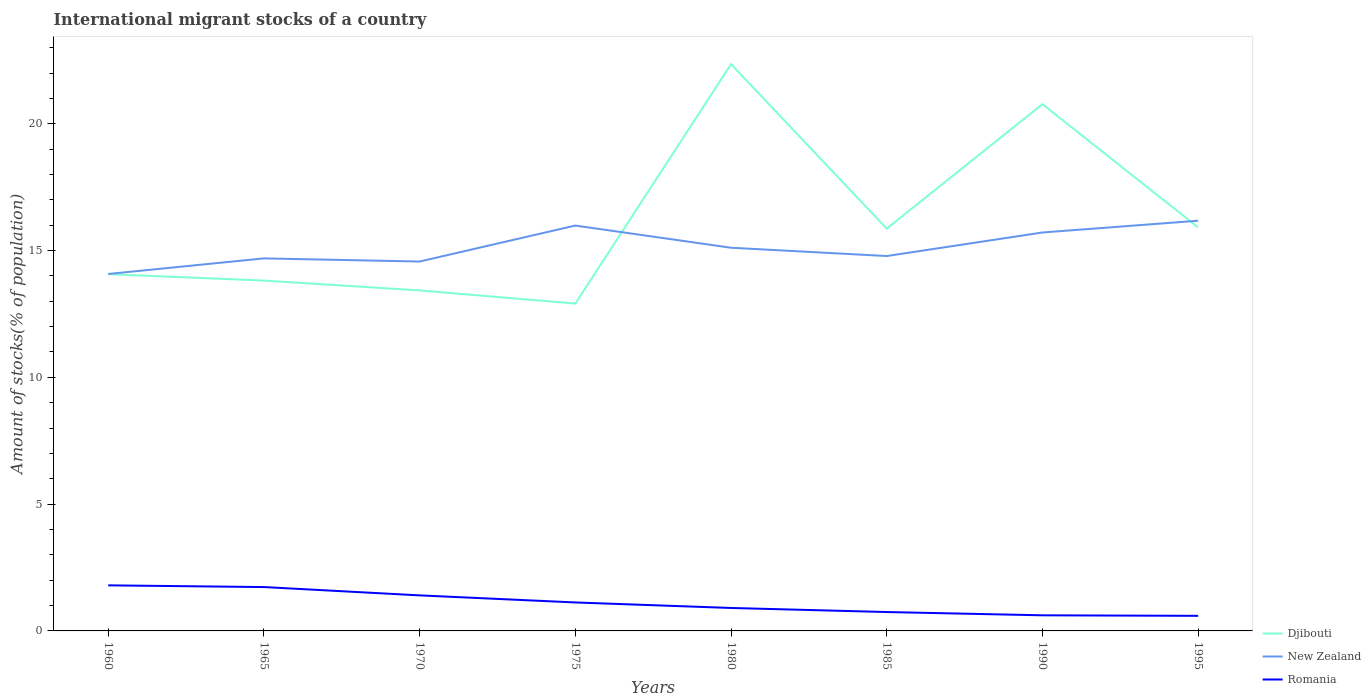How many different coloured lines are there?
Provide a succinct answer. 3. Across all years, what is the maximum amount of stocks in in Romania?
Provide a succinct answer. 0.6. In which year was the amount of stocks in in New Zealand maximum?
Your response must be concise. 1960. What is the total amount of stocks in in Djibouti in the graph?
Keep it short and to the point. -3. What is the difference between the highest and the second highest amount of stocks in in Djibouti?
Keep it short and to the point. 9.44. What is the difference between the highest and the lowest amount of stocks in in Romania?
Offer a terse response. 4. Is the amount of stocks in in New Zealand strictly greater than the amount of stocks in in Djibouti over the years?
Your response must be concise. No. How many lines are there?
Your answer should be very brief. 3. Where does the legend appear in the graph?
Make the answer very short. Bottom right. How are the legend labels stacked?
Your response must be concise. Vertical. What is the title of the graph?
Your answer should be compact. International migrant stocks of a country. What is the label or title of the X-axis?
Make the answer very short. Years. What is the label or title of the Y-axis?
Give a very brief answer. Amount of stocks(% of population). What is the Amount of stocks(% of population) in Djibouti in 1960?
Provide a succinct answer. 14.07. What is the Amount of stocks(% of population) in New Zealand in 1960?
Your answer should be very brief. 14.08. What is the Amount of stocks(% of population) of Romania in 1960?
Your response must be concise. 1.8. What is the Amount of stocks(% of population) of Djibouti in 1965?
Ensure brevity in your answer.  13.82. What is the Amount of stocks(% of population) of New Zealand in 1965?
Your answer should be very brief. 14.69. What is the Amount of stocks(% of population) of Romania in 1965?
Ensure brevity in your answer.  1.73. What is the Amount of stocks(% of population) in Djibouti in 1970?
Keep it short and to the point. 13.43. What is the Amount of stocks(% of population) in New Zealand in 1970?
Keep it short and to the point. 14.57. What is the Amount of stocks(% of population) of Romania in 1970?
Provide a succinct answer. 1.4. What is the Amount of stocks(% of population) in Djibouti in 1975?
Keep it short and to the point. 12.91. What is the Amount of stocks(% of population) in New Zealand in 1975?
Your answer should be very brief. 15.99. What is the Amount of stocks(% of population) in Romania in 1975?
Ensure brevity in your answer.  1.12. What is the Amount of stocks(% of population) of Djibouti in 1980?
Provide a succinct answer. 22.35. What is the Amount of stocks(% of population) in New Zealand in 1980?
Your answer should be compact. 15.11. What is the Amount of stocks(% of population) in Romania in 1980?
Provide a succinct answer. 0.91. What is the Amount of stocks(% of population) of Djibouti in 1985?
Provide a succinct answer. 15.87. What is the Amount of stocks(% of population) in New Zealand in 1985?
Offer a very short reply. 14.78. What is the Amount of stocks(% of population) of Romania in 1985?
Offer a very short reply. 0.75. What is the Amount of stocks(% of population) in Djibouti in 1990?
Your answer should be very brief. 20.77. What is the Amount of stocks(% of population) of New Zealand in 1990?
Give a very brief answer. 15.71. What is the Amount of stocks(% of population) of Romania in 1990?
Make the answer very short. 0.62. What is the Amount of stocks(% of population) of Djibouti in 1995?
Give a very brief answer. 15.91. What is the Amount of stocks(% of population) in New Zealand in 1995?
Keep it short and to the point. 16.18. What is the Amount of stocks(% of population) in Romania in 1995?
Your response must be concise. 0.6. Across all years, what is the maximum Amount of stocks(% of population) in Djibouti?
Offer a terse response. 22.35. Across all years, what is the maximum Amount of stocks(% of population) of New Zealand?
Your answer should be very brief. 16.18. Across all years, what is the maximum Amount of stocks(% of population) of Romania?
Offer a very short reply. 1.8. Across all years, what is the minimum Amount of stocks(% of population) of Djibouti?
Your response must be concise. 12.91. Across all years, what is the minimum Amount of stocks(% of population) of New Zealand?
Your answer should be compact. 14.08. Across all years, what is the minimum Amount of stocks(% of population) in Romania?
Your answer should be very brief. 0.6. What is the total Amount of stocks(% of population) in Djibouti in the graph?
Your response must be concise. 129.12. What is the total Amount of stocks(% of population) of New Zealand in the graph?
Provide a short and direct response. 121.1. What is the total Amount of stocks(% of population) of Romania in the graph?
Keep it short and to the point. 8.91. What is the difference between the Amount of stocks(% of population) of Djibouti in 1960 and that in 1965?
Offer a very short reply. 0.25. What is the difference between the Amount of stocks(% of population) in New Zealand in 1960 and that in 1965?
Provide a short and direct response. -0.62. What is the difference between the Amount of stocks(% of population) of Romania in 1960 and that in 1965?
Offer a terse response. 0.07. What is the difference between the Amount of stocks(% of population) of Djibouti in 1960 and that in 1970?
Provide a short and direct response. 0.64. What is the difference between the Amount of stocks(% of population) in New Zealand in 1960 and that in 1970?
Provide a succinct answer. -0.49. What is the difference between the Amount of stocks(% of population) of Romania in 1960 and that in 1970?
Your answer should be very brief. 0.4. What is the difference between the Amount of stocks(% of population) in Djibouti in 1960 and that in 1975?
Ensure brevity in your answer.  1.16. What is the difference between the Amount of stocks(% of population) of New Zealand in 1960 and that in 1975?
Provide a succinct answer. -1.91. What is the difference between the Amount of stocks(% of population) in Romania in 1960 and that in 1975?
Keep it short and to the point. 0.68. What is the difference between the Amount of stocks(% of population) in Djibouti in 1960 and that in 1980?
Provide a short and direct response. -8.28. What is the difference between the Amount of stocks(% of population) in New Zealand in 1960 and that in 1980?
Ensure brevity in your answer.  -1.03. What is the difference between the Amount of stocks(% of population) of Romania in 1960 and that in 1980?
Keep it short and to the point. 0.89. What is the difference between the Amount of stocks(% of population) of Djibouti in 1960 and that in 1985?
Provide a succinct answer. -1.8. What is the difference between the Amount of stocks(% of population) of New Zealand in 1960 and that in 1985?
Keep it short and to the point. -0.71. What is the difference between the Amount of stocks(% of population) of Romania in 1960 and that in 1985?
Provide a succinct answer. 1.05. What is the difference between the Amount of stocks(% of population) in Djibouti in 1960 and that in 1990?
Offer a terse response. -6.71. What is the difference between the Amount of stocks(% of population) in New Zealand in 1960 and that in 1990?
Give a very brief answer. -1.64. What is the difference between the Amount of stocks(% of population) in Romania in 1960 and that in 1990?
Provide a succinct answer. 1.18. What is the difference between the Amount of stocks(% of population) of Djibouti in 1960 and that in 1995?
Provide a short and direct response. -1.84. What is the difference between the Amount of stocks(% of population) in New Zealand in 1960 and that in 1995?
Make the answer very short. -2.1. What is the difference between the Amount of stocks(% of population) in Romania in 1960 and that in 1995?
Provide a short and direct response. 1.2. What is the difference between the Amount of stocks(% of population) in Djibouti in 1965 and that in 1970?
Offer a terse response. 0.39. What is the difference between the Amount of stocks(% of population) in New Zealand in 1965 and that in 1970?
Offer a terse response. 0.12. What is the difference between the Amount of stocks(% of population) in Romania in 1965 and that in 1970?
Give a very brief answer. 0.33. What is the difference between the Amount of stocks(% of population) of Djibouti in 1965 and that in 1975?
Offer a terse response. 0.91. What is the difference between the Amount of stocks(% of population) of New Zealand in 1965 and that in 1975?
Your response must be concise. -1.29. What is the difference between the Amount of stocks(% of population) in Romania in 1965 and that in 1975?
Your answer should be compact. 0.61. What is the difference between the Amount of stocks(% of population) of Djibouti in 1965 and that in 1980?
Your answer should be compact. -8.53. What is the difference between the Amount of stocks(% of population) in New Zealand in 1965 and that in 1980?
Your answer should be very brief. -0.42. What is the difference between the Amount of stocks(% of population) in Romania in 1965 and that in 1980?
Provide a succinct answer. 0.82. What is the difference between the Amount of stocks(% of population) in Djibouti in 1965 and that in 1985?
Give a very brief answer. -2.05. What is the difference between the Amount of stocks(% of population) of New Zealand in 1965 and that in 1985?
Your response must be concise. -0.09. What is the difference between the Amount of stocks(% of population) in Romania in 1965 and that in 1985?
Ensure brevity in your answer.  0.98. What is the difference between the Amount of stocks(% of population) in Djibouti in 1965 and that in 1990?
Ensure brevity in your answer.  -6.96. What is the difference between the Amount of stocks(% of population) in New Zealand in 1965 and that in 1990?
Offer a terse response. -1.02. What is the difference between the Amount of stocks(% of population) of Romania in 1965 and that in 1990?
Ensure brevity in your answer.  1.11. What is the difference between the Amount of stocks(% of population) of Djibouti in 1965 and that in 1995?
Provide a short and direct response. -2.1. What is the difference between the Amount of stocks(% of population) of New Zealand in 1965 and that in 1995?
Give a very brief answer. -1.49. What is the difference between the Amount of stocks(% of population) in Romania in 1965 and that in 1995?
Keep it short and to the point. 1.13. What is the difference between the Amount of stocks(% of population) in Djibouti in 1970 and that in 1975?
Your answer should be very brief. 0.52. What is the difference between the Amount of stocks(% of population) of New Zealand in 1970 and that in 1975?
Offer a terse response. -1.42. What is the difference between the Amount of stocks(% of population) of Romania in 1970 and that in 1975?
Offer a very short reply. 0.28. What is the difference between the Amount of stocks(% of population) of Djibouti in 1970 and that in 1980?
Your response must be concise. -8.92. What is the difference between the Amount of stocks(% of population) in New Zealand in 1970 and that in 1980?
Your answer should be compact. -0.54. What is the difference between the Amount of stocks(% of population) in Romania in 1970 and that in 1980?
Your answer should be very brief. 0.5. What is the difference between the Amount of stocks(% of population) of Djibouti in 1970 and that in 1985?
Your answer should be compact. -2.44. What is the difference between the Amount of stocks(% of population) in New Zealand in 1970 and that in 1985?
Offer a terse response. -0.22. What is the difference between the Amount of stocks(% of population) of Romania in 1970 and that in 1985?
Offer a very short reply. 0.66. What is the difference between the Amount of stocks(% of population) of Djibouti in 1970 and that in 1990?
Keep it short and to the point. -7.35. What is the difference between the Amount of stocks(% of population) in New Zealand in 1970 and that in 1990?
Give a very brief answer. -1.15. What is the difference between the Amount of stocks(% of population) of Romania in 1970 and that in 1990?
Give a very brief answer. 0.79. What is the difference between the Amount of stocks(% of population) of Djibouti in 1970 and that in 1995?
Make the answer very short. -2.48. What is the difference between the Amount of stocks(% of population) in New Zealand in 1970 and that in 1995?
Provide a succinct answer. -1.61. What is the difference between the Amount of stocks(% of population) of Romania in 1970 and that in 1995?
Keep it short and to the point. 0.81. What is the difference between the Amount of stocks(% of population) in Djibouti in 1975 and that in 1980?
Make the answer very short. -9.44. What is the difference between the Amount of stocks(% of population) in New Zealand in 1975 and that in 1980?
Provide a short and direct response. 0.87. What is the difference between the Amount of stocks(% of population) of Romania in 1975 and that in 1980?
Your response must be concise. 0.22. What is the difference between the Amount of stocks(% of population) in Djibouti in 1975 and that in 1985?
Give a very brief answer. -2.96. What is the difference between the Amount of stocks(% of population) of New Zealand in 1975 and that in 1985?
Keep it short and to the point. 1.2. What is the difference between the Amount of stocks(% of population) of Romania in 1975 and that in 1985?
Make the answer very short. 0.38. What is the difference between the Amount of stocks(% of population) in Djibouti in 1975 and that in 1990?
Give a very brief answer. -7.86. What is the difference between the Amount of stocks(% of population) in New Zealand in 1975 and that in 1990?
Provide a succinct answer. 0.27. What is the difference between the Amount of stocks(% of population) of Romania in 1975 and that in 1990?
Your answer should be very brief. 0.51. What is the difference between the Amount of stocks(% of population) in Djibouti in 1975 and that in 1995?
Provide a succinct answer. -3. What is the difference between the Amount of stocks(% of population) of New Zealand in 1975 and that in 1995?
Offer a terse response. -0.19. What is the difference between the Amount of stocks(% of population) of Romania in 1975 and that in 1995?
Keep it short and to the point. 0.53. What is the difference between the Amount of stocks(% of population) in Djibouti in 1980 and that in 1985?
Provide a succinct answer. 6.48. What is the difference between the Amount of stocks(% of population) in New Zealand in 1980 and that in 1985?
Give a very brief answer. 0.33. What is the difference between the Amount of stocks(% of population) in Romania in 1980 and that in 1985?
Ensure brevity in your answer.  0.16. What is the difference between the Amount of stocks(% of population) in Djibouti in 1980 and that in 1990?
Your answer should be very brief. 1.58. What is the difference between the Amount of stocks(% of population) of New Zealand in 1980 and that in 1990?
Offer a terse response. -0.6. What is the difference between the Amount of stocks(% of population) in Romania in 1980 and that in 1990?
Your answer should be compact. 0.29. What is the difference between the Amount of stocks(% of population) in Djibouti in 1980 and that in 1995?
Provide a succinct answer. 6.44. What is the difference between the Amount of stocks(% of population) of New Zealand in 1980 and that in 1995?
Provide a succinct answer. -1.07. What is the difference between the Amount of stocks(% of population) of Romania in 1980 and that in 1995?
Your answer should be compact. 0.31. What is the difference between the Amount of stocks(% of population) in Djibouti in 1985 and that in 1990?
Make the answer very short. -4.91. What is the difference between the Amount of stocks(% of population) in New Zealand in 1985 and that in 1990?
Make the answer very short. -0.93. What is the difference between the Amount of stocks(% of population) of Romania in 1985 and that in 1990?
Your answer should be very brief. 0.13. What is the difference between the Amount of stocks(% of population) in Djibouti in 1985 and that in 1995?
Offer a terse response. -0.05. What is the difference between the Amount of stocks(% of population) in New Zealand in 1985 and that in 1995?
Ensure brevity in your answer.  -1.39. What is the difference between the Amount of stocks(% of population) of Romania in 1985 and that in 1995?
Offer a very short reply. 0.15. What is the difference between the Amount of stocks(% of population) in Djibouti in 1990 and that in 1995?
Offer a very short reply. 4.86. What is the difference between the Amount of stocks(% of population) of New Zealand in 1990 and that in 1995?
Provide a short and direct response. -0.46. What is the difference between the Amount of stocks(% of population) in Romania in 1990 and that in 1995?
Keep it short and to the point. 0.02. What is the difference between the Amount of stocks(% of population) of Djibouti in 1960 and the Amount of stocks(% of population) of New Zealand in 1965?
Your answer should be compact. -0.62. What is the difference between the Amount of stocks(% of population) of Djibouti in 1960 and the Amount of stocks(% of population) of Romania in 1965?
Offer a very short reply. 12.34. What is the difference between the Amount of stocks(% of population) of New Zealand in 1960 and the Amount of stocks(% of population) of Romania in 1965?
Offer a terse response. 12.35. What is the difference between the Amount of stocks(% of population) in Djibouti in 1960 and the Amount of stocks(% of population) in New Zealand in 1970?
Provide a succinct answer. -0.5. What is the difference between the Amount of stocks(% of population) in Djibouti in 1960 and the Amount of stocks(% of population) in Romania in 1970?
Ensure brevity in your answer.  12.67. What is the difference between the Amount of stocks(% of population) of New Zealand in 1960 and the Amount of stocks(% of population) of Romania in 1970?
Your answer should be compact. 12.67. What is the difference between the Amount of stocks(% of population) in Djibouti in 1960 and the Amount of stocks(% of population) in New Zealand in 1975?
Your answer should be compact. -1.92. What is the difference between the Amount of stocks(% of population) in Djibouti in 1960 and the Amount of stocks(% of population) in Romania in 1975?
Ensure brevity in your answer.  12.95. What is the difference between the Amount of stocks(% of population) in New Zealand in 1960 and the Amount of stocks(% of population) in Romania in 1975?
Your answer should be compact. 12.95. What is the difference between the Amount of stocks(% of population) in Djibouti in 1960 and the Amount of stocks(% of population) in New Zealand in 1980?
Keep it short and to the point. -1.04. What is the difference between the Amount of stocks(% of population) in Djibouti in 1960 and the Amount of stocks(% of population) in Romania in 1980?
Ensure brevity in your answer.  13.16. What is the difference between the Amount of stocks(% of population) in New Zealand in 1960 and the Amount of stocks(% of population) in Romania in 1980?
Ensure brevity in your answer.  13.17. What is the difference between the Amount of stocks(% of population) of Djibouti in 1960 and the Amount of stocks(% of population) of New Zealand in 1985?
Offer a very short reply. -0.72. What is the difference between the Amount of stocks(% of population) in Djibouti in 1960 and the Amount of stocks(% of population) in Romania in 1985?
Give a very brief answer. 13.32. What is the difference between the Amount of stocks(% of population) of New Zealand in 1960 and the Amount of stocks(% of population) of Romania in 1985?
Offer a very short reply. 13.33. What is the difference between the Amount of stocks(% of population) of Djibouti in 1960 and the Amount of stocks(% of population) of New Zealand in 1990?
Your answer should be very brief. -1.64. What is the difference between the Amount of stocks(% of population) of Djibouti in 1960 and the Amount of stocks(% of population) of Romania in 1990?
Your response must be concise. 13.45. What is the difference between the Amount of stocks(% of population) of New Zealand in 1960 and the Amount of stocks(% of population) of Romania in 1990?
Your answer should be compact. 13.46. What is the difference between the Amount of stocks(% of population) in Djibouti in 1960 and the Amount of stocks(% of population) in New Zealand in 1995?
Provide a short and direct response. -2.11. What is the difference between the Amount of stocks(% of population) in Djibouti in 1960 and the Amount of stocks(% of population) in Romania in 1995?
Give a very brief answer. 13.47. What is the difference between the Amount of stocks(% of population) of New Zealand in 1960 and the Amount of stocks(% of population) of Romania in 1995?
Provide a short and direct response. 13.48. What is the difference between the Amount of stocks(% of population) in Djibouti in 1965 and the Amount of stocks(% of population) in New Zealand in 1970?
Give a very brief answer. -0.75. What is the difference between the Amount of stocks(% of population) in Djibouti in 1965 and the Amount of stocks(% of population) in Romania in 1970?
Your answer should be compact. 12.41. What is the difference between the Amount of stocks(% of population) in New Zealand in 1965 and the Amount of stocks(% of population) in Romania in 1970?
Your response must be concise. 13.29. What is the difference between the Amount of stocks(% of population) of Djibouti in 1965 and the Amount of stocks(% of population) of New Zealand in 1975?
Offer a very short reply. -2.17. What is the difference between the Amount of stocks(% of population) in Djibouti in 1965 and the Amount of stocks(% of population) in Romania in 1975?
Your answer should be very brief. 12.69. What is the difference between the Amount of stocks(% of population) of New Zealand in 1965 and the Amount of stocks(% of population) of Romania in 1975?
Your response must be concise. 13.57. What is the difference between the Amount of stocks(% of population) in Djibouti in 1965 and the Amount of stocks(% of population) in New Zealand in 1980?
Offer a terse response. -1.3. What is the difference between the Amount of stocks(% of population) in Djibouti in 1965 and the Amount of stocks(% of population) in Romania in 1980?
Keep it short and to the point. 12.91. What is the difference between the Amount of stocks(% of population) in New Zealand in 1965 and the Amount of stocks(% of population) in Romania in 1980?
Offer a terse response. 13.79. What is the difference between the Amount of stocks(% of population) in Djibouti in 1965 and the Amount of stocks(% of population) in New Zealand in 1985?
Provide a short and direct response. -0.97. What is the difference between the Amount of stocks(% of population) in Djibouti in 1965 and the Amount of stocks(% of population) in Romania in 1985?
Make the answer very short. 13.07. What is the difference between the Amount of stocks(% of population) in New Zealand in 1965 and the Amount of stocks(% of population) in Romania in 1985?
Keep it short and to the point. 13.95. What is the difference between the Amount of stocks(% of population) in Djibouti in 1965 and the Amount of stocks(% of population) in New Zealand in 1990?
Offer a very short reply. -1.9. What is the difference between the Amount of stocks(% of population) in Djibouti in 1965 and the Amount of stocks(% of population) in Romania in 1990?
Provide a succinct answer. 13.2. What is the difference between the Amount of stocks(% of population) of New Zealand in 1965 and the Amount of stocks(% of population) of Romania in 1990?
Offer a very short reply. 14.08. What is the difference between the Amount of stocks(% of population) of Djibouti in 1965 and the Amount of stocks(% of population) of New Zealand in 1995?
Your answer should be very brief. -2.36. What is the difference between the Amount of stocks(% of population) of Djibouti in 1965 and the Amount of stocks(% of population) of Romania in 1995?
Your answer should be very brief. 13.22. What is the difference between the Amount of stocks(% of population) of New Zealand in 1965 and the Amount of stocks(% of population) of Romania in 1995?
Make the answer very short. 14.1. What is the difference between the Amount of stocks(% of population) of Djibouti in 1970 and the Amount of stocks(% of population) of New Zealand in 1975?
Your answer should be compact. -2.56. What is the difference between the Amount of stocks(% of population) in Djibouti in 1970 and the Amount of stocks(% of population) in Romania in 1975?
Provide a short and direct response. 12.31. What is the difference between the Amount of stocks(% of population) in New Zealand in 1970 and the Amount of stocks(% of population) in Romania in 1975?
Offer a terse response. 13.44. What is the difference between the Amount of stocks(% of population) of Djibouti in 1970 and the Amount of stocks(% of population) of New Zealand in 1980?
Your answer should be very brief. -1.68. What is the difference between the Amount of stocks(% of population) in Djibouti in 1970 and the Amount of stocks(% of population) in Romania in 1980?
Make the answer very short. 12.52. What is the difference between the Amount of stocks(% of population) in New Zealand in 1970 and the Amount of stocks(% of population) in Romania in 1980?
Your answer should be compact. 13.66. What is the difference between the Amount of stocks(% of population) of Djibouti in 1970 and the Amount of stocks(% of population) of New Zealand in 1985?
Your answer should be compact. -1.36. What is the difference between the Amount of stocks(% of population) of Djibouti in 1970 and the Amount of stocks(% of population) of Romania in 1985?
Give a very brief answer. 12.68. What is the difference between the Amount of stocks(% of population) of New Zealand in 1970 and the Amount of stocks(% of population) of Romania in 1985?
Provide a succinct answer. 13.82. What is the difference between the Amount of stocks(% of population) of Djibouti in 1970 and the Amount of stocks(% of population) of New Zealand in 1990?
Offer a terse response. -2.28. What is the difference between the Amount of stocks(% of population) in Djibouti in 1970 and the Amount of stocks(% of population) in Romania in 1990?
Give a very brief answer. 12.81. What is the difference between the Amount of stocks(% of population) of New Zealand in 1970 and the Amount of stocks(% of population) of Romania in 1990?
Your answer should be compact. 13.95. What is the difference between the Amount of stocks(% of population) in Djibouti in 1970 and the Amount of stocks(% of population) in New Zealand in 1995?
Keep it short and to the point. -2.75. What is the difference between the Amount of stocks(% of population) in Djibouti in 1970 and the Amount of stocks(% of population) in Romania in 1995?
Provide a succinct answer. 12.83. What is the difference between the Amount of stocks(% of population) in New Zealand in 1970 and the Amount of stocks(% of population) in Romania in 1995?
Offer a very short reply. 13.97. What is the difference between the Amount of stocks(% of population) of Djibouti in 1975 and the Amount of stocks(% of population) of New Zealand in 1980?
Offer a very short reply. -2.2. What is the difference between the Amount of stocks(% of population) in Djibouti in 1975 and the Amount of stocks(% of population) in Romania in 1980?
Offer a terse response. 12. What is the difference between the Amount of stocks(% of population) of New Zealand in 1975 and the Amount of stocks(% of population) of Romania in 1980?
Your answer should be compact. 15.08. What is the difference between the Amount of stocks(% of population) in Djibouti in 1975 and the Amount of stocks(% of population) in New Zealand in 1985?
Provide a short and direct response. -1.87. What is the difference between the Amount of stocks(% of population) of Djibouti in 1975 and the Amount of stocks(% of population) of Romania in 1985?
Your answer should be compact. 12.16. What is the difference between the Amount of stocks(% of population) in New Zealand in 1975 and the Amount of stocks(% of population) in Romania in 1985?
Provide a short and direct response. 15.24. What is the difference between the Amount of stocks(% of population) of Djibouti in 1975 and the Amount of stocks(% of population) of New Zealand in 1990?
Your answer should be compact. -2.8. What is the difference between the Amount of stocks(% of population) in Djibouti in 1975 and the Amount of stocks(% of population) in Romania in 1990?
Keep it short and to the point. 12.29. What is the difference between the Amount of stocks(% of population) in New Zealand in 1975 and the Amount of stocks(% of population) in Romania in 1990?
Your answer should be very brief. 15.37. What is the difference between the Amount of stocks(% of population) of Djibouti in 1975 and the Amount of stocks(% of population) of New Zealand in 1995?
Provide a succinct answer. -3.27. What is the difference between the Amount of stocks(% of population) in Djibouti in 1975 and the Amount of stocks(% of population) in Romania in 1995?
Provide a succinct answer. 12.31. What is the difference between the Amount of stocks(% of population) in New Zealand in 1975 and the Amount of stocks(% of population) in Romania in 1995?
Make the answer very short. 15.39. What is the difference between the Amount of stocks(% of population) of Djibouti in 1980 and the Amount of stocks(% of population) of New Zealand in 1985?
Your answer should be compact. 7.57. What is the difference between the Amount of stocks(% of population) of Djibouti in 1980 and the Amount of stocks(% of population) of Romania in 1985?
Your response must be concise. 21.61. What is the difference between the Amount of stocks(% of population) of New Zealand in 1980 and the Amount of stocks(% of population) of Romania in 1985?
Your answer should be compact. 14.37. What is the difference between the Amount of stocks(% of population) in Djibouti in 1980 and the Amount of stocks(% of population) in New Zealand in 1990?
Offer a terse response. 6.64. What is the difference between the Amount of stocks(% of population) of Djibouti in 1980 and the Amount of stocks(% of population) of Romania in 1990?
Provide a succinct answer. 21.74. What is the difference between the Amount of stocks(% of population) in New Zealand in 1980 and the Amount of stocks(% of population) in Romania in 1990?
Your answer should be very brief. 14.5. What is the difference between the Amount of stocks(% of population) in Djibouti in 1980 and the Amount of stocks(% of population) in New Zealand in 1995?
Give a very brief answer. 6.17. What is the difference between the Amount of stocks(% of population) in Djibouti in 1980 and the Amount of stocks(% of population) in Romania in 1995?
Your answer should be very brief. 21.76. What is the difference between the Amount of stocks(% of population) in New Zealand in 1980 and the Amount of stocks(% of population) in Romania in 1995?
Your answer should be compact. 14.52. What is the difference between the Amount of stocks(% of population) in Djibouti in 1985 and the Amount of stocks(% of population) in New Zealand in 1990?
Make the answer very short. 0.15. What is the difference between the Amount of stocks(% of population) of Djibouti in 1985 and the Amount of stocks(% of population) of Romania in 1990?
Offer a very short reply. 15.25. What is the difference between the Amount of stocks(% of population) of New Zealand in 1985 and the Amount of stocks(% of population) of Romania in 1990?
Give a very brief answer. 14.17. What is the difference between the Amount of stocks(% of population) of Djibouti in 1985 and the Amount of stocks(% of population) of New Zealand in 1995?
Make the answer very short. -0.31. What is the difference between the Amount of stocks(% of population) in Djibouti in 1985 and the Amount of stocks(% of population) in Romania in 1995?
Ensure brevity in your answer.  15.27. What is the difference between the Amount of stocks(% of population) of New Zealand in 1985 and the Amount of stocks(% of population) of Romania in 1995?
Offer a terse response. 14.19. What is the difference between the Amount of stocks(% of population) in Djibouti in 1990 and the Amount of stocks(% of population) in New Zealand in 1995?
Your answer should be compact. 4.6. What is the difference between the Amount of stocks(% of population) in Djibouti in 1990 and the Amount of stocks(% of population) in Romania in 1995?
Offer a very short reply. 20.18. What is the difference between the Amount of stocks(% of population) in New Zealand in 1990 and the Amount of stocks(% of population) in Romania in 1995?
Keep it short and to the point. 15.12. What is the average Amount of stocks(% of population) of Djibouti per year?
Your answer should be compact. 16.14. What is the average Amount of stocks(% of population) in New Zealand per year?
Provide a succinct answer. 15.14. What is the average Amount of stocks(% of population) in Romania per year?
Keep it short and to the point. 1.11. In the year 1960, what is the difference between the Amount of stocks(% of population) in Djibouti and Amount of stocks(% of population) in New Zealand?
Offer a very short reply. -0.01. In the year 1960, what is the difference between the Amount of stocks(% of population) of Djibouti and Amount of stocks(% of population) of Romania?
Make the answer very short. 12.27. In the year 1960, what is the difference between the Amount of stocks(% of population) in New Zealand and Amount of stocks(% of population) in Romania?
Give a very brief answer. 12.28. In the year 1965, what is the difference between the Amount of stocks(% of population) in Djibouti and Amount of stocks(% of population) in New Zealand?
Provide a short and direct response. -0.88. In the year 1965, what is the difference between the Amount of stocks(% of population) in Djibouti and Amount of stocks(% of population) in Romania?
Your response must be concise. 12.09. In the year 1965, what is the difference between the Amount of stocks(% of population) in New Zealand and Amount of stocks(% of population) in Romania?
Your response must be concise. 12.96. In the year 1970, what is the difference between the Amount of stocks(% of population) in Djibouti and Amount of stocks(% of population) in New Zealand?
Give a very brief answer. -1.14. In the year 1970, what is the difference between the Amount of stocks(% of population) of Djibouti and Amount of stocks(% of population) of Romania?
Ensure brevity in your answer.  12.03. In the year 1970, what is the difference between the Amount of stocks(% of population) in New Zealand and Amount of stocks(% of population) in Romania?
Offer a very short reply. 13.17. In the year 1975, what is the difference between the Amount of stocks(% of population) of Djibouti and Amount of stocks(% of population) of New Zealand?
Your answer should be very brief. -3.08. In the year 1975, what is the difference between the Amount of stocks(% of population) of Djibouti and Amount of stocks(% of population) of Romania?
Your answer should be very brief. 11.79. In the year 1975, what is the difference between the Amount of stocks(% of population) of New Zealand and Amount of stocks(% of population) of Romania?
Your answer should be very brief. 14.86. In the year 1980, what is the difference between the Amount of stocks(% of population) in Djibouti and Amount of stocks(% of population) in New Zealand?
Offer a very short reply. 7.24. In the year 1980, what is the difference between the Amount of stocks(% of population) of Djibouti and Amount of stocks(% of population) of Romania?
Your answer should be compact. 21.45. In the year 1980, what is the difference between the Amount of stocks(% of population) of New Zealand and Amount of stocks(% of population) of Romania?
Offer a very short reply. 14.21. In the year 1985, what is the difference between the Amount of stocks(% of population) of Djibouti and Amount of stocks(% of population) of New Zealand?
Give a very brief answer. 1.08. In the year 1985, what is the difference between the Amount of stocks(% of population) in Djibouti and Amount of stocks(% of population) in Romania?
Make the answer very short. 15.12. In the year 1985, what is the difference between the Amount of stocks(% of population) of New Zealand and Amount of stocks(% of population) of Romania?
Give a very brief answer. 14.04. In the year 1990, what is the difference between the Amount of stocks(% of population) of Djibouti and Amount of stocks(% of population) of New Zealand?
Keep it short and to the point. 5.06. In the year 1990, what is the difference between the Amount of stocks(% of population) in Djibouti and Amount of stocks(% of population) in Romania?
Offer a very short reply. 20.16. In the year 1990, what is the difference between the Amount of stocks(% of population) of New Zealand and Amount of stocks(% of population) of Romania?
Your answer should be very brief. 15.1. In the year 1995, what is the difference between the Amount of stocks(% of population) of Djibouti and Amount of stocks(% of population) of New Zealand?
Provide a short and direct response. -0.26. In the year 1995, what is the difference between the Amount of stocks(% of population) in Djibouti and Amount of stocks(% of population) in Romania?
Ensure brevity in your answer.  15.32. In the year 1995, what is the difference between the Amount of stocks(% of population) in New Zealand and Amount of stocks(% of population) in Romania?
Your response must be concise. 15.58. What is the ratio of the Amount of stocks(% of population) of Djibouti in 1960 to that in 1965?
Provide a succinct answer. 1.02. What is the ratio of the Amount of stocks(% of population) of New Zealand in 1960 to that in 1965?
Offer a very short reply. 0.96. What is the ratio of the Amount of stocks(% of population) in Romania in 1960 to that in 1965?
Ensure brevity in your answer.  1.04. What is the ratio of the Amount of stocks(% of population) in Djibouti in 1960 to that in 1970?
Your answer should be compact. 1.05. What is the ratio of the Amount of stocks(% of population) of New Zealand in 1960 to that in 1970?
Give a very brief answer. 0.97. What is the ratio of the Amount of stocks(% of population) in Romania in 1960 to that in 1970?
Provide a succinct answer. 1.28. What is the ratio of the Amount of stocks(% of population) in Djibouti in 1960 to that in 1975?
Make the answer very short. 1.09. What is the ratio of the Amount of stocks(% of population) of New Zealand in 1960 to that in 1975?
Provide a short and direct response. 0.88. What is the ratio of the Amount of stocks(% of population) in Romania in 1960 to that in 1975?
Provide a short and direct response. 1.6. What is the ratio of the Amount of stocks(% of population) of Djibouti in 1960 to that in 1980?
Provide a succinct answer. 0.63. What is the ratio of the Amount of stocks(% of population) of New Zealand in 1960 to that in 1980?
Offer a terse response. 0.93. What is the ratio of the Amount of stocks(% of population) of Romania in 1960 to that in 1980?
Provide a succinct answer. 1.99. What is the ratio of the Amount of stocks(% of population) of Djibouti in 1960 to that in 1985?
Your response must be concise. 0.89. What is the ratio of the Amount of stocks(% of population) in New Zealand in 1960 to that in 1985?
Provide a short and direct response. 0.95. What is the ratio of the Amount of stocks(% of population) of Romania in 1960 to that in 1985?
Provide a short and direct response. 2.41. What is the ratio of the Amount of stocks(% of population) of Djibouti in 1960 to that in 1990?
Your answer should be very brief. 0.68. What is the ratio of the Amount of stocks(% of population) of New Zealand in 1960 to that in 1990?
Your answer should be compact. 0.9. What is the ratio of the Amount of stocks(% of population) of Romania in 1960 to that in 1990?
Give a very brief answer. 2.92. What is the ratio of the Amount of stocks(% of population) in Djibouti in 1960 to that in 1995?
Make the answer very short. 0.88. What is the ratio of the Amount of stocks(% of population) in New Zealand in 1960 to that in 1995?
Ensure brevity in your answer.  0.87. What is the ratio of the Amount of stocks(% of population) in Romania in 1960 to that in 1995?
Provide a short and direct response. 3.02. What is the ratio of the Amount of stocks(% of population) of Djibouti in 1965 to that in 1970?
Your answer should be compact. 1.03. What is the ratio of the Amount of stocks(% of population) of New Zealand in 1965 to that in 1970?
Make the answer very short. 1.01. What is the ratio of the Amount of stocks(% of population) in Romania in 1965 to that in 1970?
Keep it short and to the point. 1.23. What is the ratio of the Amount of stocks(% of population) in Djibouti in 1965 to that in 1975?
Your answer should be very brief. 1.07. What is the ratio of the Amount of stocks(% of population) of New Zealand in 1965 to that in 1975?
Offer a terse response. 0.92. What is the ratio of the Amount of stocks(% of population) of Romania in 1965 to that in 1975?
Give a very brief answer. 1.54. What is the ratio of the Amount of stocks(% of population) of Djibouti in 1965 to that in 1980?
Your answer should be very brief. 0.62. What is the ratio of the Amount of stocks(% of population) of New Zealand in 1965 to that in 1980?
Keep it short and to the point. 0.97. What is the ratio of the Amount of stocks(% of population) of Romania in 1965 to that in 1980?
Provide a succinct answer. 1.91. What is the ratio of the Amount of stocks(% of population) in Djibouti in 1965 to that in 1985?
Offer a terse response. 0.87. What is the ratio of the Amount of stocks(% of population) in New Zealand in 1965 to that in 1985?
Give a very brief answer. 0.99. What is the ratio of the Amount of stocks(% of population) in Romania in 1965 to that in 1985?
Your answer should be very brief. 2.32. What is the ratio of the Amount of stocks(% of population) of Djibouti in 1965 to that in 1990?
Give a very brief answer. 0.67. What is the ratio of the Amount of stocks(% of population) of New Zealand in 1965 to that in 1990?
Ensure brevity in your answer.  0.94. What is the ratio of the Amount of stocks(% of population) of Romania in 1965 to that in 1990?
Your response must be concise. 2.81. What is the ratio of the Amount of stocks(% of population) in Djibouti in 1965 to that in 1995?
Provide a short and direct response. 0.87. What is the ratio of the Amount of stocks(% of population) of New Zealand in 1965 to that in 1995?
Your answer should be compact. 0.91. What is the ratio of the Amount of stocks(% of population) of Romania in 1965 to that in 1995?
Offer a terse response. 2.91. What is the ratio of the Amount of stocks(% of population) of Djibouti in 1970 to that in 1975?
Your response must be concise. 1.04. What is the ratio of the Amount of stocks(% of population) in New Zealand in 1970 to that in 1975?
Provide a short and direct response. 0.91. What is the ratio of the Amount of stocks(% of population) of Romania in 1970 to that in 1975?
Your response must be concise. 1.25. What is the ratio of the Amount of stocks(% of population) of Djibouti in 1970 to that in 1980?
Provide a short and direct response. 0.6. What is the ratio of the Amount of stocks(% of population) of New Zealand in 1970 to that in 1980?
Offer a very short reply. 0.96. What is the ratio of the Amount of stocks(% of population) in Romania in 1970 to that in 1980?
Give a very brief answer. 1.55. What is the ratio of the Amount of stocks(% of population) of Djibouti in 1970 to that in 1985?
Keep it short and to the point. 0.85. What is the ratio of the Amount of stocks(% of population) in New Zealand in 1970 to that in 1985?
Your answer should be very brief. 0.99. What is the ratio of the Amount of stocks(% of population) in Romania in 1970 to that in 1985?
Keep it short and to the point. 1.88. What is the ratio of the Amount of stocks(% of population) in Djibouti in 1970 to that in 1990?
Provide a succinct answer. 0.65. What is the ratio of the Amount of stocks(% of population) of New Zealand in 1970 to that in 1990?
Provide a short and direct response. 0.93. What is the ratio of the Amount of stocks(% of population) in Romania in 1970 to that in 1990?
Make the answer very short. 2.28. What is the ratio of the Amount of stocks(% of population) in Djibouti in 1970 to that in 1995?
Your answer should be compact. 0.84. What is the ratio of the Amount of stocks(% of population) in New Zealand in 1970 to that in 1995?
Offer a very short reply. 0.9. What is the ratio of the Amount of stocks(% of population) of Romania in 1970 to that in 1995?
Your answer should be compact. 2.36. What is the ratio of the Amount of stocks(% of population) of Djibouti in 1975 to that in 1980?
Offer a terse response. 0.58. What is the ratio of the Amount of stocks(% of population) in New Zealand in 1975 to that in 1980?
Keep it short and to the point. 1.06. What is the ratio of the Amount of stocks(% of population) in Romania in 1975 to that in 1980?
Offer a terse response. 1.24. What is the ratio of the Amount of stocks(% of population) of Djibouti in 1975 to that in 1985?
Offer a very short reply. 0.81. What is the ratio of the Amount of stocks(% of population) in New Zealand in 1975 to that in 1985?
Offer a very short reply. 1.08. What is the ratio of the Amount of stocks(% of population) in Romania in 1975 to that in 1985?
Your answer should be compact. 1.51. What is the ratio of the Amount of stocks(% of population) in Djibouti in 1975 to that in 1990?
Offer a terse response. 0.62. What is the ratio of the Amount of stocks(% of population) in New Zealand in 1975 to that in 1990?
Provide a short and direct response. 1.02. What is the ratio of the Amount of stocks(% of population) of Romania in 1975 to that in 1990?
Give a very brief answer. 1.82. What is the ratio of the Amount of stocks(% of population) in Djibouti in 1975 to that in 1995?
Keep it short and to the point. 0.81. What is the ratio of the Amount of stocks(% of population) in Romania in 1975 to that in 1995?
Provide a short and direct response. 1.89. What is the ratio of the Amount of stocks(% of population) of Djibouti in 1980 to that in 1985?
Ensure brevity in your answer.  1.41. What is the ratio of the Amount of stocks(% of population) of New Zealand in 1980 to that in 1985?
Your answer should be very brief. 1.02. What is the ratio of the Amount of stocks(% of population) of Romania in 1980 to that in 1985?
Your answer should be compact. 1.21. What is the ratio of the Amount of stocks(% of population) of Djibouti in 1980 to that in 1990?
Your answer should be compact. 1.08. What is the ratio of the Amount of stocks(% of population) in New Zealand in 1980 to that in 1990?
Make the answer very short. 0.96. What is the ratio of the Amount of stocks(% of population) of Romania in 1980 to that in 1990?
Keep it short and to the point. 1.47. What is the ratio of the Amount of stocks(% of population) in Djibouti in 1980 to that in 1995?
Your answer should be compact. 1.4. What is the ratio of the Amount of stocks(% of population) of New Zealand in 1980 to that in 1995?
Keep it short and to the point. 0.93. What is the ratio of the Amount of stocks(% of population) of Romania in 1980 to that in 1995?
Your answer should be very brief. 1.52. What is the ratio of the Amount of stocks(% of population) in Djibouti in 1985 to that in 1990?
Your answer should be compact. 0.76. What is the ratio of the Amount of stocks(% of population) of New Zealand in 1985 to that in 1990?
Provide a short and direct response. 0.94. What is the ratio of the Amount of stocks(% of population) in Romania in 1985 to that in 1990?
Give a very brief answer. 1.21. What is the ratio of the Amount of stocks(% of population) of New Zealand in 1985 to that in 1995?
Make the answer very short. 0.91. What is the ratio of the Amount of stocks(% of population) of Romania in 1985 to that in 1995?
Keep it short and to the point. 1.25. What is the ratio of the Amount of stocks(% of population) of Djibouti in 1990 to that in 1995?
Keep it short and to the point. 1.31. What is the ratio of the Amount of stocks(% of population) in New Zealand in 1990 to that in 1995?
Offer a very short reply. 0.97. What is the ratio of the Amount of stocks(% of population) in Romania in 1990 to that in 1995?
Your answer should be compact. 1.03. What is the difference between the highest and the second highest Amount of stocks(% of population) in Djibouti?
Your answer should be very brief. 1.58. What is the difference between the highest and the second highest Amount of stocks(% of population) of New Zealand?
Make the answer very short. 0.19. What is the difference between the highest and the second highest Amount of stocks(% of population) in Romania?
Provide a succinct answer. 0.07. What is the difference between the highest and the lowest Amount of stocks(% of population) in Djibouti?
Ensure brevity in your answer.  9.44. What is the difference between the highest and the lowest Amount of stocks(% of population) of New Zealand?
Your answer should be very brief. 2.1. What is the difference between the highest and the lowest Amount of stocks(% of population) of Romania?
Offer a very short reply. 1.2. 